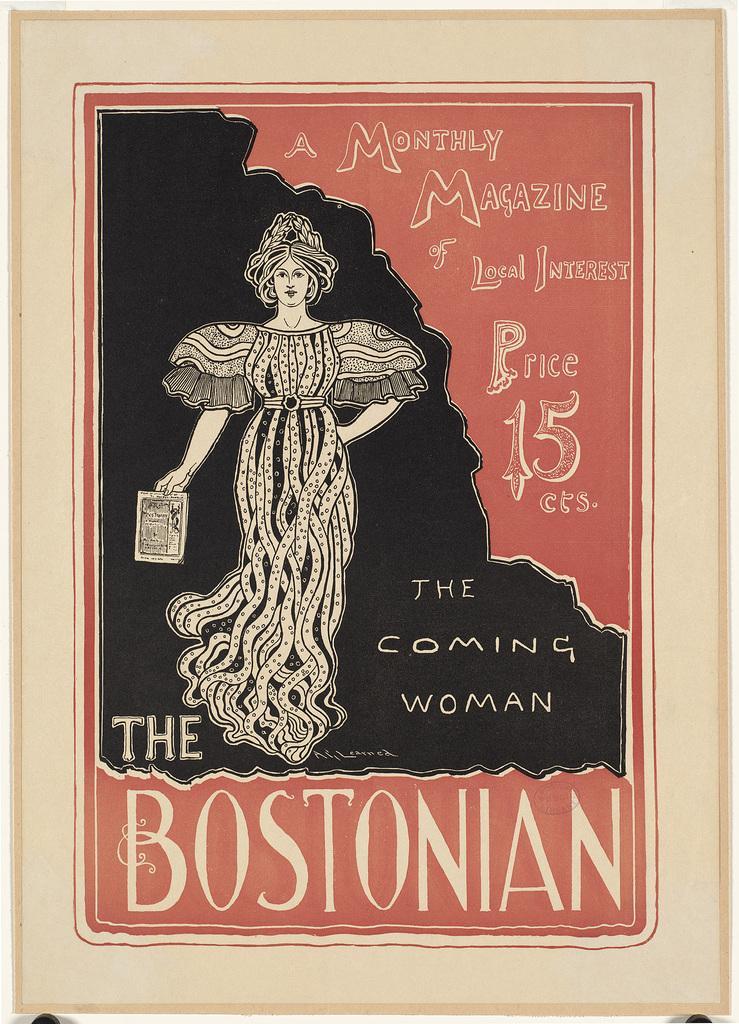How would you summarize this image in a sentence or two? In this image we can see a poster. In the poster we can see an edited image of a person holding an object. On the right side, we can see some text. At the bottom we can see some text. 